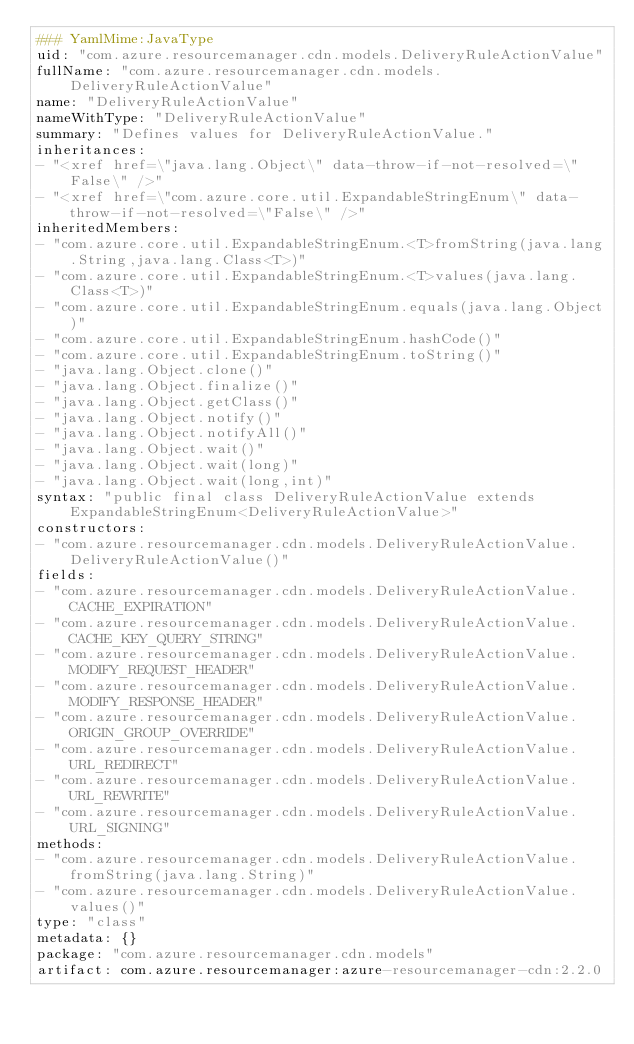<code> <loc_0><loc_0><loc_500><loc_500><_YAML_>### YamlMime:JavaType
uid: "com.azure.resourcemanager.cdn.models.DeliveryRuleActionValue"
fullName: "com.azure.resourcemanager.cdn.models.DeliveryRuleActionValue"
name: "DeliveryRuleActionValue"
nameWithType: "DeliveryRuleActionValue"
summary: "Defines values for DeliveryRuleActionValue."
inheritances:
- "<xref href=\"java.lang.Object\" data-throw-if-not-resolved=\"False\" />"
- "<xref href=\"com.azure.core.util.ExpandableStringEnum\" data-throw-if-not-resolved=\"False\" />"
inheritedMembers:
- "com.azure.core.util.ExpandableStringEnum.<T>fromString(java.lang.String,java.lang.Class<T>)"
- "com.azure.core.util.ExpandableStringEnum.<T>values(java.lang.Class<T>)"
- "com.azure.core.util.ExpandableStringEnum.equals(java.lang.Object)"
- "com.azure.core.util.ExpandableStringEnum.hashCode()"
- "com.azure.core.util.ExpandableStringEnum.toString()"
- "java.lang.Object.clone()"
- "java.lang.Object.finalize()"
- "java.lang.Object.getClass()"
- "java.lang.Object.notify()"
- "java.lang.Object.notifyAll()"
- "java.lang.Object.wait()"
- "java.lang.Object.wait(long)"
- "java.lang.Object.wait(long,int)"
syntax: "public final class DeliveryRuleActionValue extends ExpandableStringEnum<DeliveryRuleActionValue>"
constructors:
- "com.azure.resourcemanager.cdn.models.DeliveryRuleActionValue.DeliveryRuleActionValue()"
fields:
- "com.azure.resourcemanager.cdn.models.DeliveryRuleActionValue.CACHE_EXPIRATION"
- "com.azure.resourcemanager.cdn.models.DeliveryRuleActionValue.CACHE_KEY_QUERY_STRING"
- "com.azure.resourcemanager.cdn.models.DeliveryRuleActionValue.MODIFY_REQUEST_HEADER"
- "com.azure.resourcemanager.cdn.models.DeliveryRuleActionValue.MODIFY_RESPONSE_HEADER"
- "com.azure.resourcemanager.cdn.models.DeliveryRuleActionValue.ORIGIN_GROUP_OVERRIDE"
- "com.azure.resourcemanager.cdn.models.DeliveryRuleActionValue.URL_REDIRECT"
- "com.azure.resourcemanager.cdn.models.DeliveryRuleActionValue.URL_REWRITE"
- "com.azure.resourcemanager.cdn.models.DeliveryRuleActionValue.URL_SIGNING"
methods:
- "com.azure.resourcemanager.cdn.models.DeliveryRuleActionValue.fromString(java.lang.String)"
- "com.azure.resourcemanager.cdn.models.DeliveryRuleActionValue.values()"
type: "class"
metadata: {}
package: "com.azure.resourcemanager.cdn.models"
artifact: com.azure.resourcemanager:azure-resourcemanager-cdn:2.2.0
</code> 